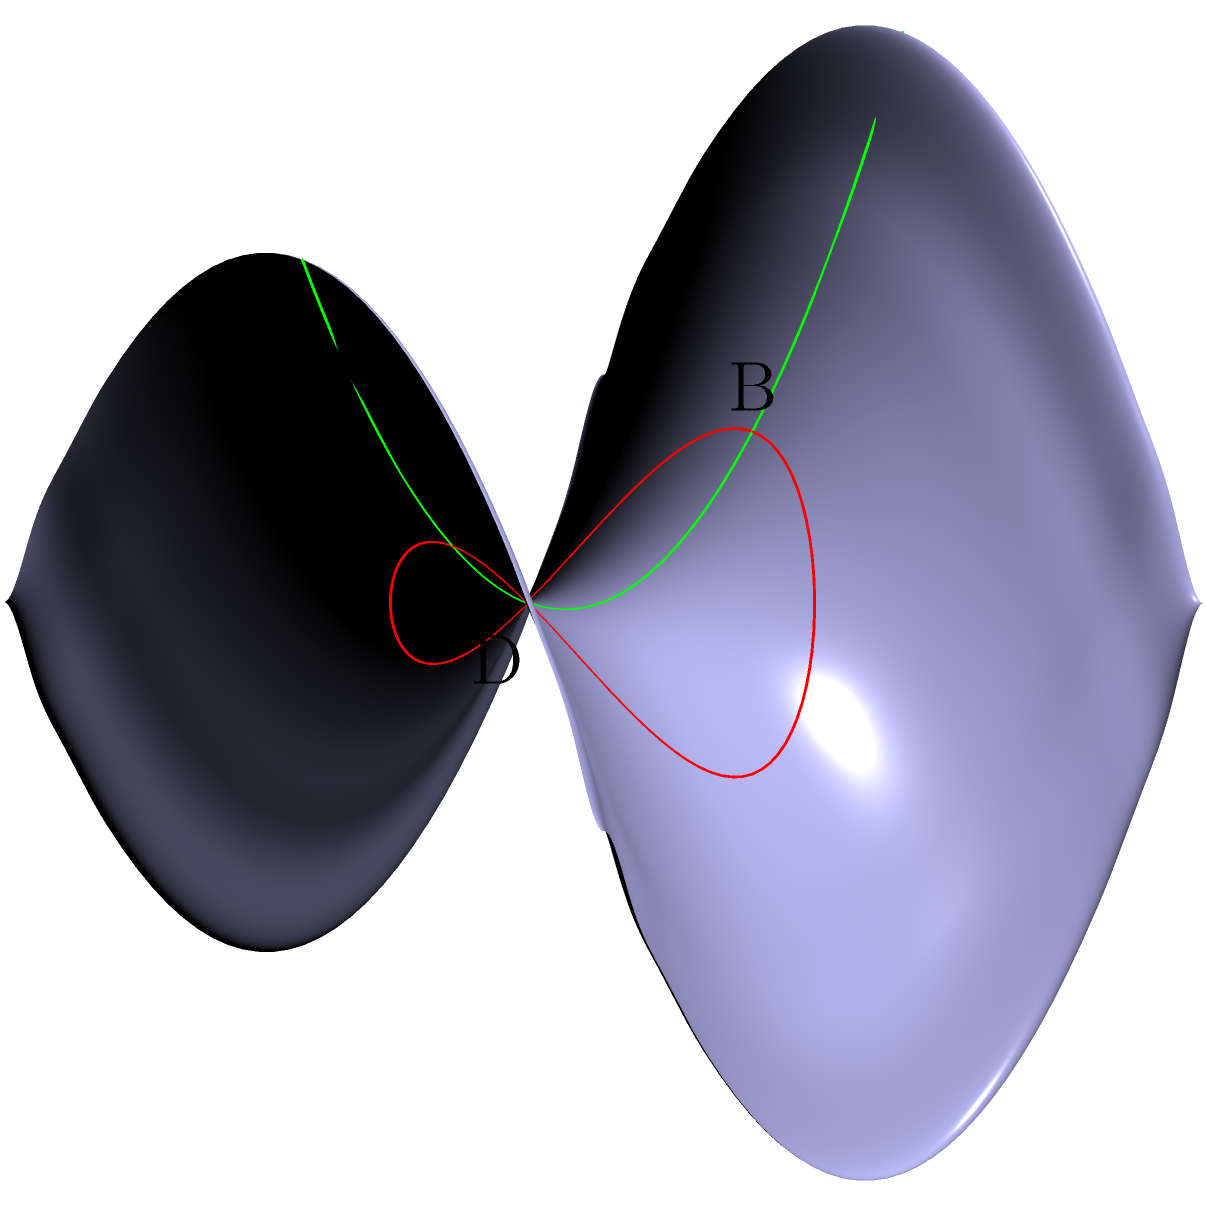On the saddle-shaped surface shown above, two geodesics are drawn: a circular path (red) and a straight line (green). Consider points A, B on the green geodesic, and C, D on the red geodesic. Which of the following statements is true about these geodesics?

a) The green geodesic is shorter than the red geodesic for traveling between any two points.
b) The red geodesic always maintains a constant distance from the origin.
c) The green geodesic represents the path of minimum curvature on the surface.
d) Both geodesics are examples of great circles on this surface. Let's analyze each option step-by-step:

1) The green geodesic is a straight line passing through the origin of the saddle surface. It represents the path of least distance between any two points along its trajectory.

2) The red geodesic is a circular path on the surface. It does not maintain a constant distance from the origin, as the surface's curvature varies.

3) The green geodesic follows the line of symmetry of the saddle surface where the curvature changes from positive to negative. This path minimizes the overall curvature of the trajectory.

4) Great circles are geodesics on a sphere, not on a saddle-shaped surface. This concept doesn't apply here.

5) The green geodesic represents the path of steepest ascent/descent on the surface, following the principal directions of curvature.

6) The red geodesic, while also being a geodesic, does not always provide the shortest path between two points on the surface.

Based on these observations, we can conclude that the statement about the green geodesic representing the path of minimum curvature is the most accurate.
Answer: c) The green geodesic represents the path of minimum curvature on the surface. 